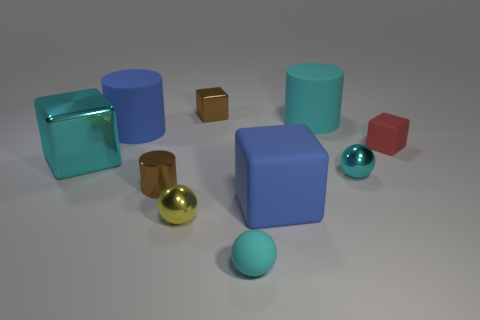Subtract all cylinders. How many objects are left? 7 Add 2 large rubber cylinders. How many large rubber cylinders are left? 4 Add 1 small brown cylinders. How many small brown cylinders exist? 2 Subtract 1 yellow spheres. How many objects are left? 9 Subtract all cylinders. Subtract all cyan rubber objects. How many objects are left? 5 